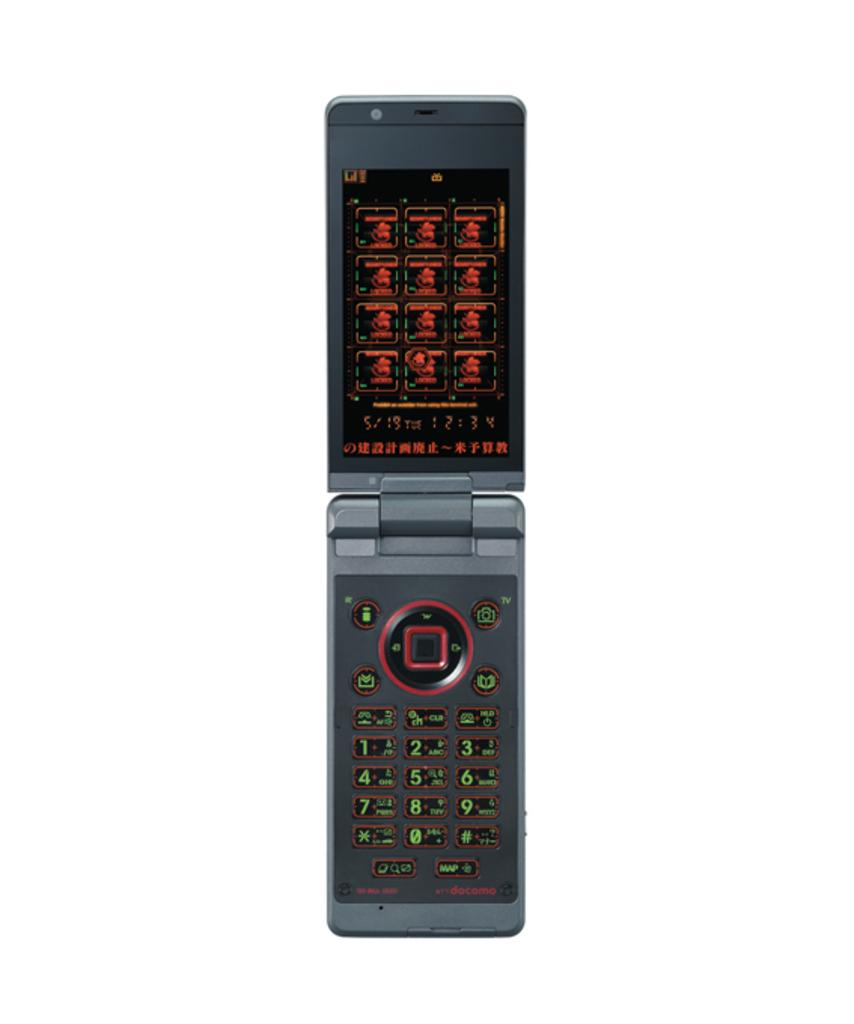<image>
Provide a brief description of the given image. A flip phone shows that the date is 5/19. 